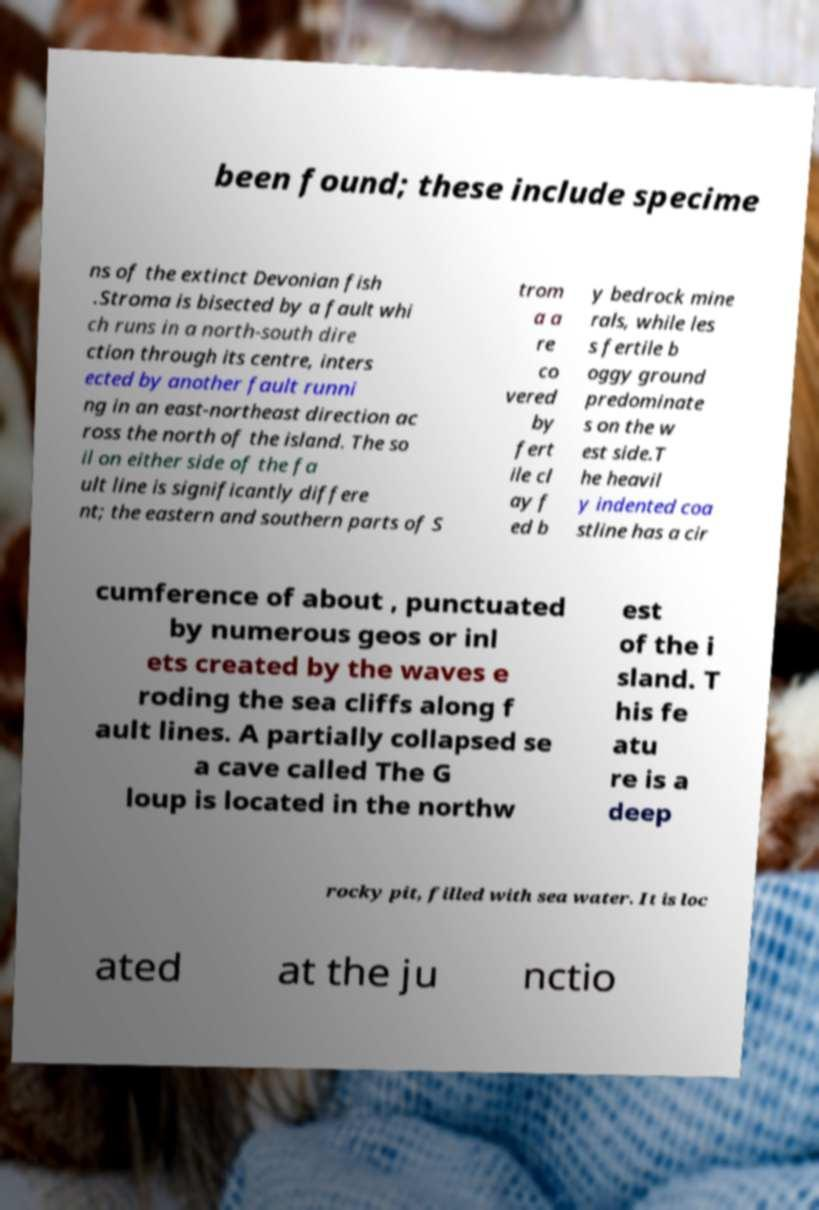For documentation purposes, I need the text within this image transcribed. Could you provide that? been found; these include specime ns of the extinct Devonian fish .Stroma is bisected by a fault whi ch runs in a north-south dire ction through its centre, inters ected by another fault runni ng in an east-northeast direction ac ross the north of the island. The so il on either side of the fa ult line is significantly differe nt; the eastern and southern parts of S trom a a re co vered by fert ile cl ay f ed b y bedrock mine rals, while les s fertile b oggy ground predominate s on the w est side.T he heavil y indented coa stline has a cir cumference of about , punctuated by numerous geos or inl ets created by the waves e roding the sea cliffs along f ault lines. A partially collapsed se a cave called The G loup is located in the northw est of the i sland. T his fe atu re is a deep rocky pit, filled with sea water. It is loc ated at the ju nctio 